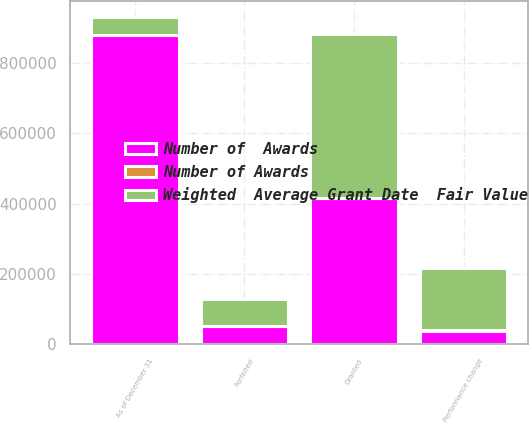Convert chart to OTSL. <chart><loc_0><loc_0><loc_500><loc_500><stacked_bar_chart><ecel><fcel>Granted<fcel>Performance change<fcel>Forfeited<fcel>As of December 31<nl><fcel>Weighted  Average Grant Date  Fair Value<fcel>467531<fcel>178838<fcel>78481<fcel>51064<nl><fcel>Number of Awards<fcel>81.55<fcel>81.27<fcel>80.21<fcel>79.27<nl><fcel>Number of  Awards<fcel>415024<fcel>39323<fcel>51064<fcel>878872<nl></chart> 